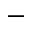Convert formula to latex. <formula><loc_0><loc_0><loc_500><loc_500>-</formula> 